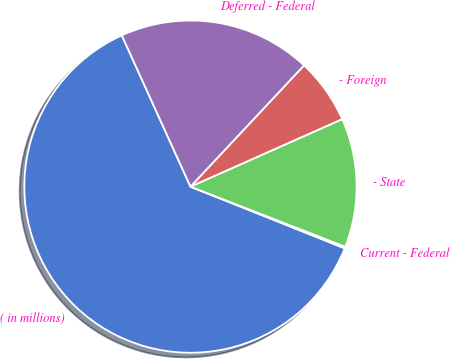Convert chart. <chart><loc_0><loc_0><loc_500><loc_500><pie_chart><fcel>( in millions)<fcel>Current - Federal<fcel>- State<fcel>- Foreign<fcel>Deferred - Federal<nl><fcel>62.17%<fcel>0.16%<fcel>12.56%<fcel>6.36%<fcel>18.76%<nl></chart> 